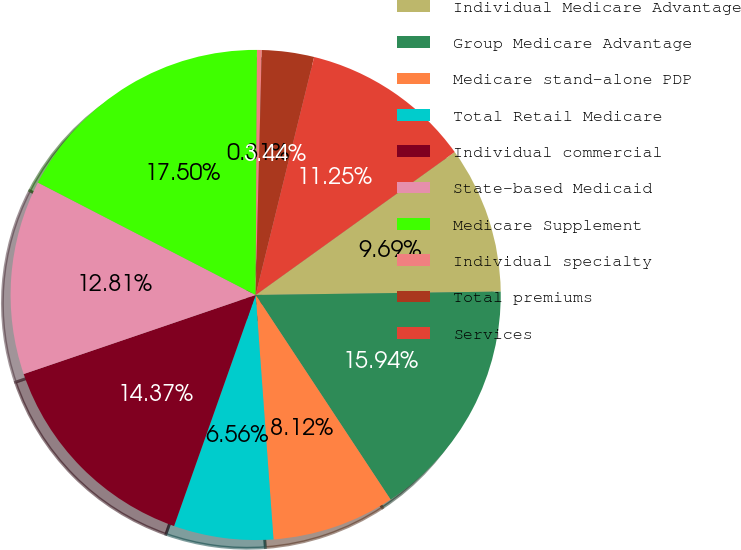Convert chart to OTSL. <chart><loc_0><loc_0><loc_500><loc_500><pie_chart><fcel>Individual Medicare Advantage<fcel>Group Medicare Advantage<fcel>Medicare stand-alone PDP<fcel>Total Retail Medicare<fcel>Individual commercial<fcel>State-based Medicaid<fcel>Medicare Supplement<fcel>Individual specialty<fcel>Total premiums<fcel>Services<nl><fcel>9.69%<fcel>15.94%<fcel>8.12%<fcel>6.56%<fcel>14.37%<fcel>12.81%<fcel>17.5%<fcel>0.31%<fcel>3.44%<fcel>11.25%<nl></chart> 